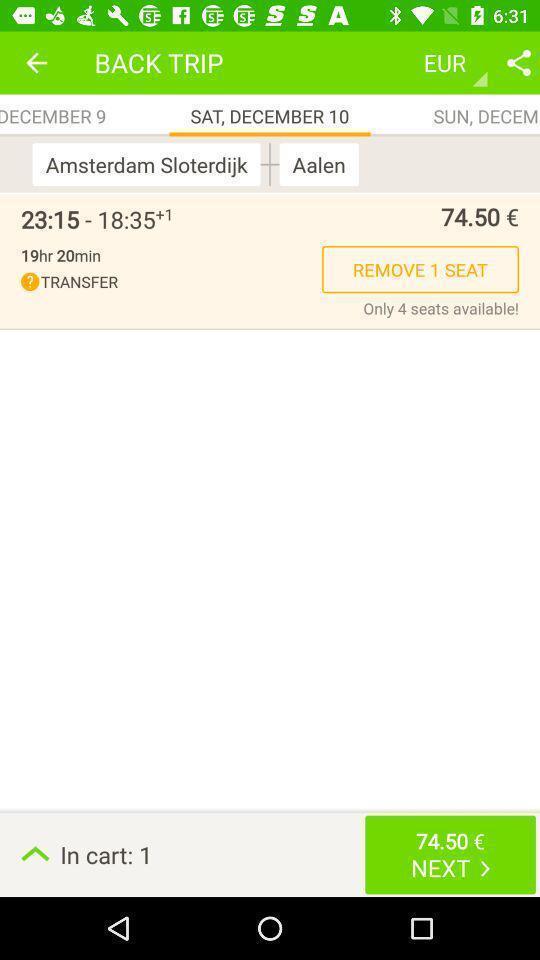Provide a detailed account of this screenshot. Page showing seat confirmation option in travel app. 